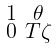Convert formula to latex. <formula><loc_0><loc_0><loc_500><loc_500>\begin{smallmatrix} 1 & \theta \\ 0 & T \zeta \end{smallmatrix}</formula> 